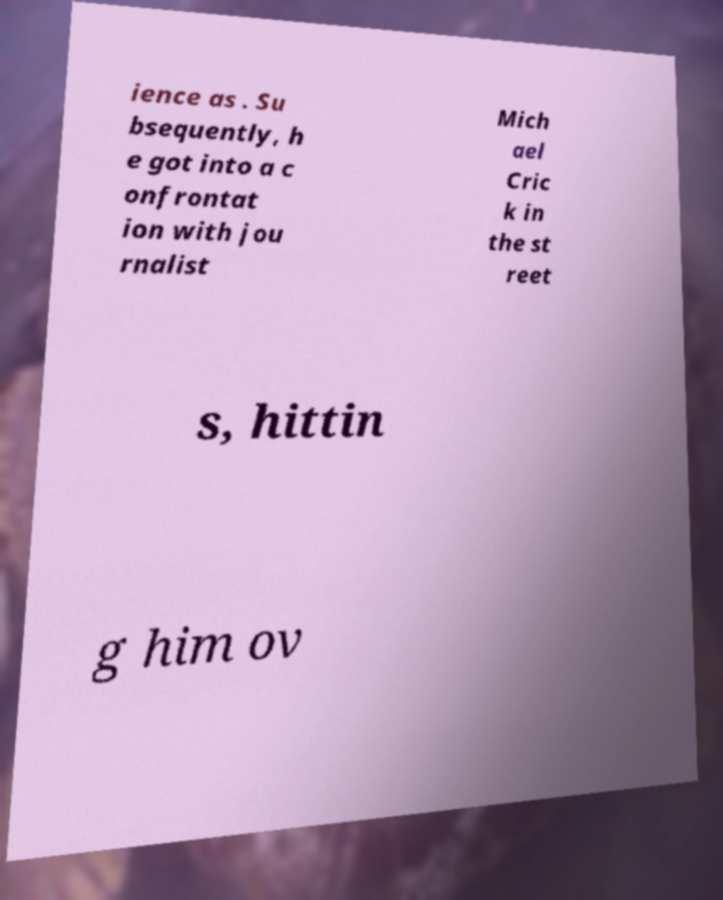Can you accurately transcribe the text from the provided image for me? ience as . Su bsequently, h e got into a c onfrontat ion with jou rnalist Mich ael Cric k in the st reet s, hittin g him ov 